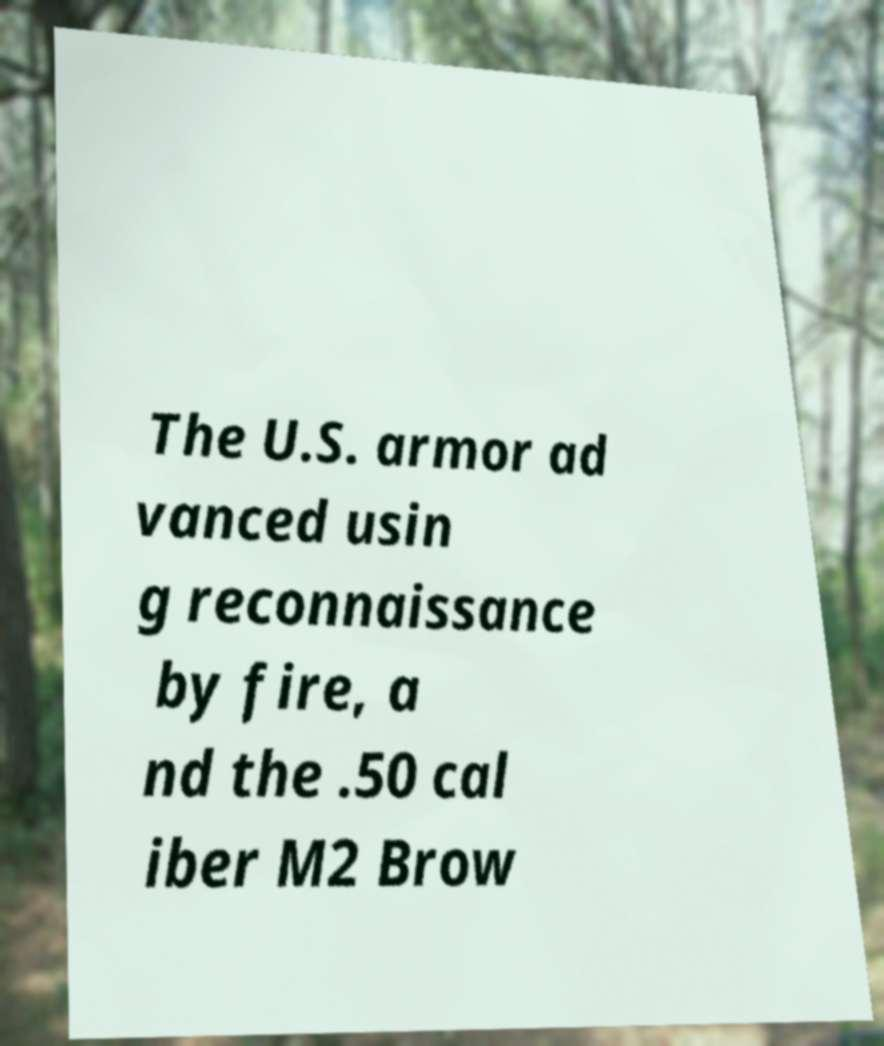For documentation purposes, I need the text within this image transcribed. Could you provide that? The U.S. armor ad vanced usin g reconnaissance by fire, a nd the .50 cal iber M2 Brow 